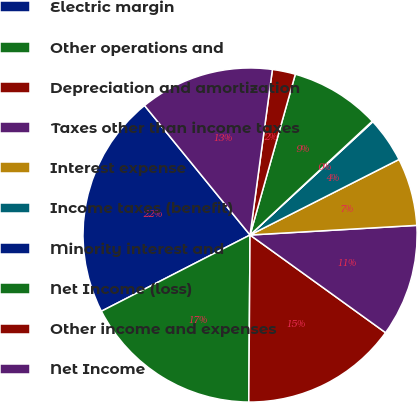Convert chart. <chart><loc_0><loc_0><loc_500><loc_500><pie_chart><fcel>Electric margin<fcel>Other operations and<fcel>Depreciation and amortization<fcel>Taxes other than income taxes<fcel>Interest expense<fcel>Income taxes (benefit)<fcel>Minority interest and<fcel>Net Income (loss)<fcel>Other income and expenses<fcel>Net Income<nl><fcel>21.66%<fcel>17.34%<fcel>15.18%<fcel>10.86%<fcel>6.55%<fcel>4.39%<fcel>0.07%<fcel>8.7%<fcel>2.23%<fcel>13.02%<nl></chart> 